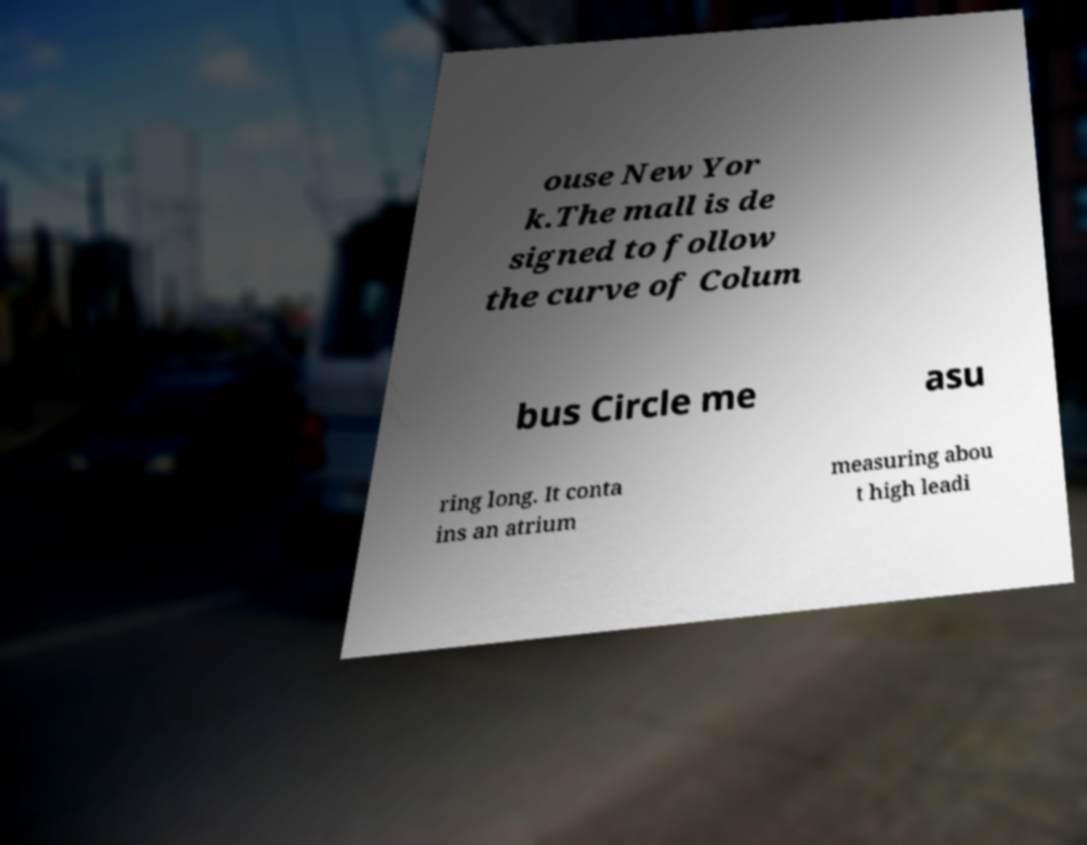There's text embedded in this image that I need extracted. Can you transcribe it verbatim? ouse New Yor k.The mall is de signed to follow the curve of Colum bus Circle me asu ring long. It conta ins an atrium measuring abou t high leadi 